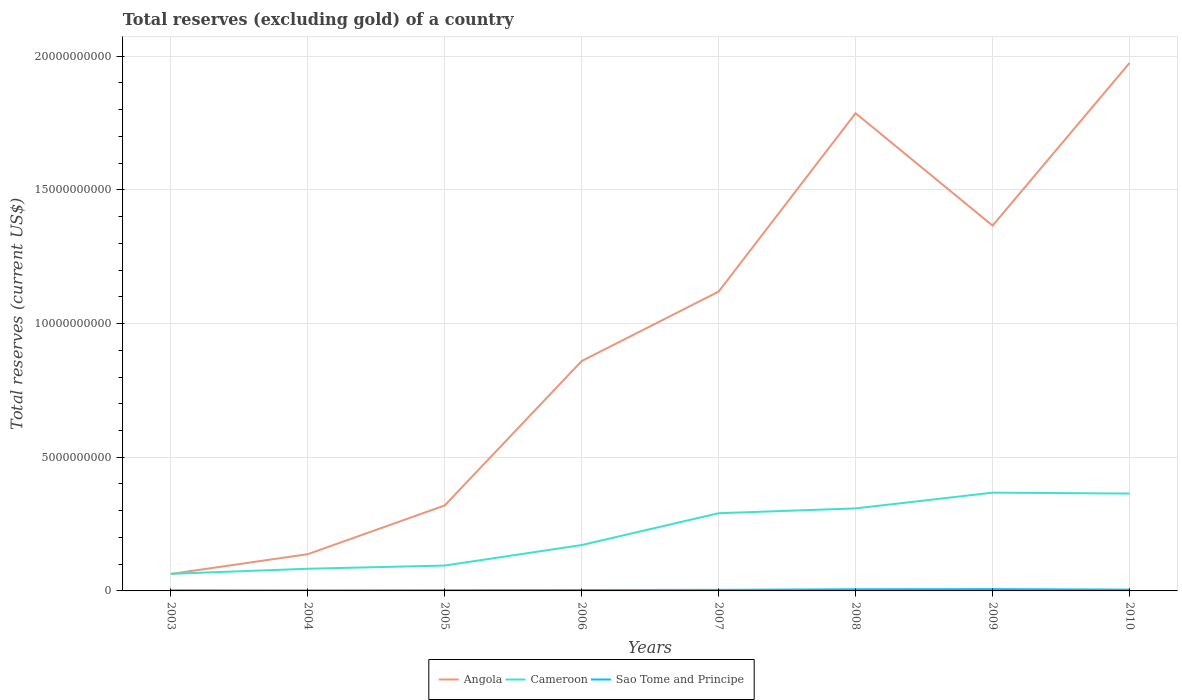How many different coloured lines are there?
Offer a terse response. 3. Does the line corresponding to Cameroon intersect with the line corresponding to Angola?
Offer a very short reply. Yes. Across all years, what is the maximum total reserves (excluding gold) in Cameroon?
Make the answer very short. 6.40e+08. What is the total total reserves (excluding gold) in Sao Tome and Principe in the graph?
Offer a terse response. -2.71e+07. What is the difference between the highest and the second highest total reserves (excluding gold) in Cameroon?
Your response must be concise. 3.04e+09. Is the total reserves (excluding gold) in Sao Tome and Principe strictly greater than the total reserves (excluding gold) in Angola over the years?
Provide a short and direct response. Yes. How many lines are there?
Make the answer very short. 3. What is the difference between two consecutive major ticks on the Y-axis?
Make the answer very short. 5.00e+09. Are the values on the major ticks of Y-axis written in scientific E-notation?
Make the answer very short. No. How many legend labels are there?
Your answer should be very brief. 3. How are the legend labels stacked?
Provide a short and direct response. Horizontal. What is the title of the graph?
Your answer should be very brief. Total reserves (excluding gold) of a country. What is the label or title of the X-axis?
Provide a succinct answer. Years. What is the label or title of the Y-axis?
Give a very brief answer. Total reserves (current US$). What is the Total reserves (current US$) of Angola in 2003?
Give a very brief answer. 6.34e+08. What is the Total reserves (current US$) of Cameroon in 2003?
Make the answer very short. 6.40e+08. What is the Total reserves (current US$) of Sao Tome and Principe in 2003?
Your answer should be compact. 2.55e+07. What is the Total reserves (current US$) of Angola in 2004?
Keep it short and to the point. 1.37e+09. What is the Total reserves (current US$) in Cameroon in 2004?
Your response must be concise. 8.29e+08. What is the Total reserves (current US$) of Sao Tome and Principe in 2004?
Give a very brief answer. 1.95e+07. What is the Total reserves (current US$) in Angola in 2005?
Make the answer very short. 3.20e+09. What is the Total reserves (current US$) in Cameroon in 2005?
Offer a very short reply. 9.49e+08. What is the Total reserves (current US$) in Sao Tome and Principe in 2005?
Make the answer very short. 2.67e+07. What is the Total reserves (current US$) in Angola in 2006?
Provide a succinct answer. 8.60e+09. What is the Total reserves (current US$) in Cameroon in 2006?
Provide a succinct answer. 1.72e+09. What is the Total reserves (current US$) of Sao Tome and Principe in 2006?
Your response must be concise. 3.42e+07. What is the Total reserves (current US$) of Angola in 2007?
Give a very brief answer. 1.12e+1. What is the Total reserves (current US$) in Cameroon in 2007?
Keep it short and to the point. 2.91e+09. What is the Total reserves (current US$) in Sao Tome and Principe in 2007?
Your answer should be very brief. 3.93e+07. What is the Total reserves (current US$) in Angola in 2008?
Your answer should be compact. 1.79e+1. What is the Total reserves (current US$) of Cameroon in 2008?
Keep it short and to the point. 3.09e+09. What is the Total reserves (current US$) in Sao Tome and Principe in 2008?
Ensure brevity in your answer.  6.13e+07. What is the Total reserves (current US$) in Angola in 2009?
Your response must be concise. 1.37e+1. What is the Total reserves (current US$) in Cameroon in 2009?
Ensure brevity in your answer.  3.68e+09. What is the Total reserves (current US$) of Sao Tome and Principe in 2009?
Make the answer very short. 6.67e+07. What is the Total reserves (current US$) of Angola in 2010?
Ensure brevity in your answer.  1.97e+1. What is the Total reserves (current US$) in Cameroon in 2010?
Ensure brevity in your answer.  3.64e+09. What is the Total reserves (current US$) of Sao Tome and Principe in 2010?
Give a very brief answer. 4.82e+07. Across all years, what is the maximum Total reserves (current US$) in Angola?
Your response must be concise. 1.97e+1. Across all years, what is the maximum Total reserves (current US$) in Cameroon?
Give a very brief answer. 3.68e+09. Across all years, what is the maximum Total reserves (current US$) in Sao Tome and Principe?
Make the answer very short. 6.67e+07. Across all years, what is the minimum Total reserves (current US$) of Angola?
Ensure brevity in your answer.  6.34e+08. Across all years, what is the minimum Total reserves (current US$) of Cameroon?
Provide a short and direct response. 6.40e+08. Across all years, what is the minimum Total reserves (current US$) in Sao Tome and Principe?
Your answer should be very brief. 1.95e+07. What is the total Total reserves (current US$) in Angola in the graph?
Ensure brevity in your answer.  7.63e+1. What is the total Total reserves (current US$) of Cameroon in the graph?
Ensure brevity in your answer.  1.74e+1. What is the total Total reserves (current US$) in Sao Tome and Principe in the graph?
Your answer should be compact. 3.21e+08. What is the difference between the Total reserves (current US$) in Angola in 2003 and that in 2004?
Your response must be concise. -7.40e+08. What is the difference between the Total reserves (current US$) of Cameroon in 2003 and that in 2004?
Your response must be concise. -1.90e+08. What is the difference between the Total reserves (current US$) in Sao Tome and Principe in 2003 and that in 2004?
Offer a terse response. 5.97e+06. What is the difference between the Total reserves (current US$) in Angola in 2003 and that in 2005?
Your response must be concise. -2.56e+09. What is the difference between the Total reserves (current US$) of Cameroon in 2003 and that in 2005?
Offer a terse response. -3.10e+08. What is the difference between the Total reserves (current US$) in Sao Tome and Principe in 2003 and that in 2005?
Keep it short and to the point. -1.23e+06. What is the difference between the Total reserves (current US$) of Angola in 2003 and that in 2006?
Make the answer very short. -7.96e+09. What is the difference between the Total reserves (current US$) of Cameroon in 2003 and that in 2006?
Your response must be concise. -1.08e+09. What is the difference between the Total reserves (current US$) in Sao Tome and Principe in 2003 and that in 2006?
Provide a succinct answer. -8.71e+06. What is the difference between the Total reserves (current US$) in Angola in 2003 and that in 2007?
Your response must be concise. -1.06e+1. What is the difference between the Total reserves (current US$) in Cameroon in 2003 and that in 2007?
Keep it short and to the point. -2.27e+09. What is the difference between the Total reserves (current US$) of Sao Tome and Principe in 2003 and that in 2007?
Your response must be concise. -1.39e+07. What is the difference between the Total reserves (current US$) in Angola in 2003 and that in 2008?
Offer a terse response. -1.72e+1. What is the difference between the Total reserves (current US$) in Cameroon in 2003 and that in 2008?
Provide a succinct answer. -2.45e+09. What is the difference between the Total reserves (current US$) in Sao Tome and Principe in 2003 and that in 2008?
Provide a succinct answer. -3.58e+07. What is the difference between the Total reserves (current US$) of Angola in 2003 and that in 2009?
Make the answer very short. -1.30e+1. What is the difference between the Total reserves (current US$) of Cameroon in 2003 and that in 2009?
Provide a short and direct response. -3.04e+09. What is the difference between the Total reserves (current US$) in Sao Tome and Principe in 2003 and that in 2009?
Make the answer very short. -4.12e+07. What is the difference between the Total reserves (current US$) in Angola in 2003 and that in 2010?
Offer a very short reply. -1.91e+1. What is the difference between the Total reserves (current US$) in Cameroon in 2003 and that in 2010?
Keep it short and to the point. -3.00e+09. What is the difference between the Total reserves (current US$) in Sao Tome and Principe in 2003 and that in 2010?
Your answer should be very brief. -2.27e+07. What is the difference between the Total reserves (current US$) of Angola in 2004 and that in 2005?
Your answer should be compact. -1.82e+09. What is the difference between the Total reserves (current US$) of Cameroon in 2004 and that in 2005?
Offer a terse response. -1.20e+08. What is the difference between the Total reserves (current US$) in Sao Tome and Principe in 2004 and that in 2005?
Provide a short and direct response. -7.20e+06. What is the difference between the Total reserves (current US$) of Angola in 2004 and that in 2006?
Your answer should be very brief. -7.22e+09. What is the difference between the Total reserves (current US$) in Cameroon in 2004 and that in 2006?
Make the answer very short. -8.87e+08. What is the difference between the Total reserves (current US$) in Sao Tome and Principe in 2004 and that in 2006?
Provide a short and direct response. -1.47e+07. What is the difference between the Total reserves (current US$) of Angola in 2004 and that in 2007?
Give a very brief answer. -9.82e+09. What is the difference between the Total reserves (current US$) of Cameroon in 2004 and that in 2007?
Offer a very short reply. -2.08e+09. What is the difference between the Total reserves (current US$) in Sao Tome and Principe in 2004 and that in 2007?
Your answer should be compact. -1.98e+07. What is the difference between the Total reserves (current US$) of Angola in 2004 and that in 2008?
Offer a very short reply. -1.65e+1. What is the difference between the Total reserves (current US$) in Cameroon in 2004 and that in 2008?
Offer a very short reply. -2.26e+09. What is the difference between the Total reserves (current US$) in Sao Tome and Principe in 2004 and that in 2008?
Your response must be concise. -4.18e+07. What is the difference between the Total reserves (current US$) of Angola in 2004 and that in 2009?
Your answer should be compact. -1.23e+1. What is the difference between the Total reserves (current US$) in Cameroon in 2004 and that in 2009?
Provide a succinct answer. -2.85e+09. What is the difference between the Total reserves (current US$) in Sao Tome and Principe in 2004 and that in 2009?
Your response must be concise. -4.72e+07. What is the difference between the Total reserves (current US$) of Angola in 2004 and that in 2010?
Keep it short and to the point. -1.84e+1. What is the difference between the Total reserves (current US$) in Cameroon in 2004 and that in 2010?
Offer a very short reply. -2.81e+09. What is the difference between the Total reserves (current US$) of Sao Tome and Principe in 2004 and that in 2010?
Offer a terse response. -2.87e+07. What is the difference between the Total reserves (current US$) in Angola in 2005 and that in 2006?
Provide a short and direct response. -5.40e+09. What is the difference between the Total reserves (current US$) in Cameroon in 2005 and that in 2006?
Ensure brevity in your answer.  -7.67e+08. What is the difference between the Total reserves (current US$) of Sao Tome and Principe in 2005 and that in 2006?
Make the answer very short. -7.48e+06. What is the difference between the Total reserves (current US$) in Angola in 2005 and that in 2007?
Give a very brief answer. -8.00e+09. What is the difference between the Total reserves (current US$) in Cameroon in 2005 and that in 2007?
Offer a very short reply. -1.96e+09. What is the difference between the Total reserves (current US$) of Sao Tome and Principe in 2005 and that in 2007?
Give a very brief answer. -1.26e+07. What is the difference between the Total reserves (current US$) in Angola in 2005 and that in 2008?
Provide a succinct answer. -1.47e+1. What is the difference between the Total reserves (current US$) in Cameroon in 2005 and that in 2008?
Ensure brevity in your answer.  -2.14e+09. What is the difference between the Total reserves (current US$) in Sao Tome and Principe in 2005 and that in 2008?
Keep it short and to the point. -3.46e+07. What is the difference between the Total reserves (current US$) in Angola in 2005 and that in 2009?
Your answer should be very brief. -1.05e+1. What is the difference between the Total reserves (current US$) of Cameroon in 2005 and that in 2009?
Provide a succinct answer. -2.73e+09. What is the difference between the Total reserves (current US$) of Sao Tome and Principe in 2005 and that in 2009?
Your response must be concise. -4.00e+07. What is the difference between the Total reserves (current US$) in Angola in 2005 and that in 2010?
Make the answer very short. -1.66e+1. What is the difference between the Total reserves (current US$) in Cameroon in 2005 and that in 2010?
Make the answer very short. -2.69e+09. What is the difference between the Total reserves (current US$) in Sao Tome and Principe in 2005 and that in 2010?
Give a very brief answer. -2.15e+07. What is the difference between the Total reserves (current US$) of Angola in 2006 and that in 2007?
Make the answer very short. -2.60e+09. What is the difference between the Total reserves (current US$) of Cameroon in 2006 and that in 2007?
Keep it short and to the point. -1.19e+09. What is the difference between the Total reserves (current US$) in Sao Tome and Principe in 2006 and that in 2007?
Provide a succinct answer. -5.15e+06. What is the difference between the Total reserves (current US$) in Angola in 2006 and that in 2008?
Ensure brevity in your answer.  -9.27e+09. What is the difference between the Total reserves (current US$) of Cameroon in 2006 and that in 2008?
Give a very brief answer. -1.37e+09. What is the difference between the Total reserves (current US$) of Sao Tome and Principe in 2006 and that in 2008?
Offer a terse response. -2.71e+07. What is the difference between the Total reserves (current US$) in Angola in 2006 and that in 2009?
Give a very brief answer. -5.07e+09. What is the difference between the Total reserves (current US$) of Cameroon in 2006 and that in 2009?
Offer a very short reply. -1.96e+09. What is the difference between the Total reserves (current US$) in Sao Tome and Principe in 2006 and that in 2009?
Make the answer very short. -3.25e+07. What is the difference between the Total reserves (current US$) of Angola in 2006 and that in 2010?
Offer a very short reply. -1.12e+1. What is the difference between the Total reserves (current US$) in Cameroon in 2006 and that in 2010?
Your answer should be compact. -1.93e+09. What is the difference between the Total reserves (current US$) of Sao Tome and Principe in 2006 and that in 2010?
Keep it short and to the point. -1.40e+07. What is the difference between the Total reserves (current US$) in Angola in 2007 and that in 2008?
Your answer should be compact. -6.67e+09. What is the difference between the Total reserves (current US$) in Cameroon in 2007 and that in 2008?
Your response must be concise. -1.80e+08. What is the difference between the Total reserves (current US$) of Sao Tome and Principe in 2007 and that in 2008?
Make the answer very short. -2.20e+07. What is the difference between the Total reserves (current US$) in Angola in 2007 and that in 2009?
Ensure brevity in your answer.  -2.47e+09. What is the difference between the Total reserves (current US$) of Cameroon in 2007 and that in 2009?
Your answer should be very brief. -7.69e+08. What is the difference between the Total reserves (current US$) of Sao Tome and Principe in 2007 and that in 2009?
Give a very brief answer. -2.73e+07. What is the difference between the Total reserves (current US$) of Angola in 2007 and that in 2010?
Provide a succinct answer. -8.55e+09. What is the difference between the Total reserves (current US$) in Cameroon in 2007 and that in 2010?
Your response must be concise. -7.36e+08. What is the difference between the Total reserves (current US$) of Sao Tome and Principe in 2007 and that in 2010?
Your answer should be very brief. -8.84e+06. What is the difference between the Total reserves (current US$) in Angola in 2008 and that in 2009?
Offer a very short reply. 4.21e+09. What is the difference between the Total reserves (current US$) in Cameroon in 2008 and that in 2009?
Your response must be concise. -5.89e+08. What is the difference between the Total reserves (current US$) in Sao Tome and Principe in 2008 and that in 2009?
Ensure brevity in your answer.  -5.37e+06. What is the difference between the Total reserves (current US$) in Angola in 2008 and that in 2010?
Offer a very short reply. -1.88e+09. What is the difference between the Total reserves (current US$) of Cameroon in 2008 and that in 2010?
Your answer should be compact. -5.56e+08. What is the difference between the Total reserves (current US$) in Sao Tome and Principe in 2008 and that in 2010?
Offer a terse response. 1.31e+07. What is the difference between the Total reserves (current US$) in Angola in 2009 and that in 2010?
Offer a terse response. -6.09e+09. What is the difference between the Total reserves (current US$) in Cameroon in 2009 and that in 2010?
Offer a terse response. 3.29e+07. What is the difference between the Total reserves (current US$) in Sao Tome and Principe in 2009 and that in 2010?
Give a very brief answer. 1.85e+07. What is the difference between the Total reserves (current US$) of Angola in 2003 and the Total reserves (current US$) of Cameroon in 2004?
Provide a succinct answer. -1.95e+08. What is the difference between the Total reserves (current US$) in Angola in 2003 and the Total reserves (current US$) in Sao Tome and Principe in 2004?
Make the answer very short. 6.15e+08. What is the difference between the Total reserves (current US$) of Cameroon in 2003 and the Total reserves (current US$) of Sao Tome and Principe in 2004?
Your answer should be very brief. 6.20e+08. What is the difference between the Total reserves (current US$) in Angola in 2003 and the Total reserves (current US$) in Cameroon in 2005?
Give a very brief answer. -3.15e+08. What is the difference between the Total reserves (current US$) in Angola in 2003 and the Total reserves (current US$) in Sao Tome and Principe in 2005?
Your response must be concise. 6.07e+08. What is the difference between the Total reserves (current US$) of Cameroon in 2003 and the Total reserves (current US$) of Sao Tome and Principe in 2005?
Offer a very short reply. 6.13e+08. What is the difference between the Total reserves (current US$) of Angola in 2003 and the Total reserves (current US$) of Cameroon in 2006?
Your answer should be compact. -1.08e+09. What is the difference between the Total reserves (current US$) of Angola in 2003 and the Total reserves (current US$) of Sao Tome and Principe in 2006?
Keep it short and to the point. 6.00e+08. What is the difference between the Total reserves (current US$) of Cameroon in 2003 and the Total reserves (current US$) of Sao Tome and Principe in 2006?
Make the answer very short. 6.05e+08. What is the difference between the Total reserves (current US$) in Angola in 2003 and the Total reserves (current US$) in Cameroon in 2007?
Give a very brief answer. -2.27e+09. What is the difference between the Total reserves (current US$) in Angola in 2003 and the Total reserves (current US$) in Sao Tome and Principe in 2007?
Offer a very short reply. 5.95e+08. What is the difference between the Total reserves (current US$) in Cameroon in 2003 and the Total reserves (current US$) in Sao Tome and Principe in 2007?
Give a very brief answer. 6.00e+08. What is the difference between the Total reserves (current US$) of Angola in 2003 and the Total reserves (current US$) of Cameroon in 2008?
Make the answer very short. -2.45e+09. What is the difference between the Total reserves (current US$) in Angola in 2003 and the Total reserves (current US$) in Sao Tome and Principe in 2008?
Your answer should be very brief. 5.73e+08. What is the difference between the Total reserves (current US$) in Cameroon in 2003 and the Total reserves (current US$) in Sao Tome and Principe in 2008?
Offer a terse response. 5.78e+08. What is the difference between the Total reserves (current US$) in Angola in 2003 and the Total reserves (current US$) in Cameroon in 2009?
Your response must be concise. -3.04e+09. What is the difference between the Total reserves (current US$) of Angola in 2003 and the Total reserves (current US$) of Sao Tome and Principe in 2009?
Offer a very short reply. 5.68e+08. What is the difference between the Total reserves (current US$) in Cameroon in 2003 and the Total reserves (current US$) in Sao Tome and Principe in 2009?
Your answer should be compact. 5.73e+08. What is the difference between the Total reserves (current US$) in Angola in 2003 and the Total reserves (current US$) in Cameroon in 2010?
Your answer should be compact. -3.01e+09. What is the difference between the Total reserves (current US$) of Angola in 2003 and the Total reserves (current US$) of Sao Tome and Principe in 2010?
Your response must be concise. 5.86e+08. What is the difference between the Total reserves (current US$) of Cameroon in 2003 and the Total reserves (current US$) of Sao Tome and Principe in 2010?
Offer a terse response. 5.91e+08. What is the difference between the Total reserves (current US$) in Angola in 2004 and the Total reserves (current US$) in Cameroon in 2005?
Provide a succinct answer. 4.25e+08. What is the difference between the Total reserves (current US$) of Angola in 2004 and the Total reserves (current US$) of Sao Tome and Principe in 2005?
Keep it short and to the point. 1.35e+09. What is the difference between the Total reserves (current US$) in Cameroon in 2004 and the Total reserves (current US$) in Sao Tome and Principe in 2005?
Your response must be concise. 8.03e+08. What is the difference between the Total reserves (current US$) in Angola in 2004 and the Total reserves (current US$) in Cameroon in 2006?
Your response must be concise. -3.42e+08. What is the difference between the Total reserves (current US$) in Angola in 2004 and the Total reserves (current US$) in Sao Tome and Principe in 2006?
Make the answer very short. 1.34e+09. What is the difference between the Total reserves (current US$) of Cameroon in 2004 and the Total reserves (current US$) of Sao Tome and Principe in 2006?
Make the answer very short. 7.95e+08. What is the difference between the Total reserves (current US$) in Angola in 2004 and the Total reserves (current US$) in Cameroon in 2007?
Provide a succinct answer. -1.53e+09. What is the difference between the Total reserves (current US$) of Angola in 2004 and the Total reserves (current US$) of Sao Tome and Principe in 2007?
Provide a succinct answer. 1.33e+09. What is the difference between the Total reserves (current US$) of Cameroon in 2004 and the Total reserves (current US$) of Sao Tome and Principe in 2007?
Offer a terse response. 7.90e+08. What is the difference between the Total reserves (current US$) in Angola in 2004 and the Total reserves (current US$) in Cameroon in 2008?
Offer a very short reply. -1.71e+09. What is the difference between the Total reserves (current US$) of Angola in 2004 and the Total reserves (current US$) of Sao Tome and Principe in 2008?
Ensure brevity in your answer.  1.31e+09. What is the difference between the Total reserves (current US$) of Cameroon in 2004 and the Total reserves (current US$) of Sao Tome and Principe in 2008?
Make the answer very short. 7.68e+08. What is the difference between the Total reserves (current US$) of Angola in 2004 and the Total reserves (current US$) of Cameroon in 2009?
Offer a terse response. -2.30e+09. What is the difference between the Total reserves (current US$) in Angola in 2004 and the Total reserves (current US$) in Sao Tome and Principe in 2009?
Offer a very short reply. 1.31e+09. What is the difference between the Total reserves (current US$) of Cameroon in 2004 and the Total reserves (current US$) of Sao Tome and Principe in 2009?
Offer a terse response. 7.63e+08. What is the difference between the Total reserves (current US$) of Angola in 2004 and the Total reserves (current US$) of Cameroon in 2010?
Make the answer very short. -2.27e+09. What is the difference between the Total reserves (current US$) in Angola in 2004 and the Total reserves (current US$) in Sao Tome and Principe in 2010?
Provide a short and direct response. 1.33e+09. What is the difference between the Total reserves (current US$) in Cameroon in 2004 and the Total reserves (current US$) in Sao Tome and Principe in 2010?
Your answer should be compact. 7.81e+08. What is the difference between the Total reserves (current US$) in Angola in 2005 and the Total reserves (current US$) in Cameroon in 2006?
Make the answer very short. 1.48e+09. What is the difference between the Total reserves (current US$) of Angola in 2005 and the Total reserves (current US$) of Sao Tome and Principe in 2006?
Offer a terse response. 3.16e+09. What is the difference between the Total reserves (current US$) in Cameroon in 2005 and the Total reserves (current US$) in Sao Tome and Principe in 2006?
Give a very brief answer. 9.15e+08. What is the difference between the Total reserves (current US$) in Angola in 2005 and the Total reserves (current US$) in Cameroon in 2007?
Give a very brief answer. 2.90e+08. What is the difference between the Total reserves (current US$) in Angola in 2005 and the Total reserves (current US$) in Sao Tome and Principe in 2007?
Provide a succinct answer. 3.16e+09. What is the difference between the Total reserves (current US$) in Cameroon in 2005 and the Total reserves (current US$) in Sao Tome and Principe in 2007?
Give a very brief answer. 9.10e+08. What is the difference between the Total reserves (current US$) of Angola in 2005 and the Total reserves (current US$) of Cameroon in 2008?
Provide a short and direct response. 1.10e+08. What is the difference between the Total reserves (current US$) of Angola in 2005 and the Total reserves (current US$) of Sao Tome and Principe in 2008?
Offer a terse response. 3.14e+09. What is the difference between the Total reserves (current US$) of Cameroon in 2005 and the Total reserves (current US$) of Sao Tome and Principe in 2008?
Offer a very short reply. 8.88e+08. What is the difference between the Total reserves (current US$) in Angola in 2005 and the Total reserves (current US$) in Cameroon in 2009?
Offer a terse response. -4.79e+08. What is the difference between the Total reserves (current US$) in Angola in 2005 and the Total reserves (current US$) in Sao Tome and Principe in 2009?
Your answer should be compact. 3.13e+09. What is the difference between the Total reserves (current US$) in Cameroon in 2005 and the Total reserves (current US$) in Sao Tome and Principe in 2009?
Provide a succinct answer. 8.83e+08. What is the difference between the Total reserves (current US$) in Angola in 2005 and the Total reserves (current US$) in Cameroon in 2010?
Your answer should be compact. -4.46e+08. What is the difference between the Total reserves (current US$) in Angola in 2005 and the Total reserves (current US$) in Sao Tome and Principe in 2010?
Make the answer very short. 3.15e+09. What is the difference between the Total reserves (current US$) of Cameroon in 2005 and the Total reserves (current US$) of Sao Tome and Principe in 2010?
Make the answer very short. 9.01e+08. What is the difference between the Total reserves (current US$) in Angola in 2006 and the Total reserves (current US$) in Cameroon in 2007?
Offer a very short reply. 5.69e+09. What is the difference between the Total reserves (current US$) of Angola in 2006 and the Total reserves (current US$) of Sao Tome and Principe in 2007?
Your answer should be compact. 8.56e+09. What is the difference between the Total reserves (current US$) of Cameroon in 2006 and the Total reserves (current US$) of Sao Tome and Principe in 2007?
Your answer should be very brief. 1.68e+09. What is the difference between the Total reserves (current US$) in Angola in 2006 and the Total reserves (current US$) in Cameroon in 2008?
Offer a terse response. 5.51e+09. What is the difference between the Total reserves (current US$) in Angola in 2006 and the Total reserves (current US$) in Sao Tome and Principe in 2008?
Provide a succinct answer. 8.54e+09. What is the difference between the Total reserves (current US$) of Cameroon in 2006 and the Total reserves (current US$) of Sao Tome and Principe in 2008?
Provide a succinct answer. 1.65e+09. What is the difference between the Total reserves (current US$) of Angola in 2006 and the Total reserves (current US$) of Cameroon in 2009?
Give a very brief answer. 4.92e+09. What is the difference between the Total reserves (current US$) of Angola in 2006 and the Total reserves (current US$) of Sao Tome and Principe in 2009?
Your response must be concise. 8.53e+09. What is the difference between the Total reserves (current US$) in Cameroon in 2006 and the Total reserves (current US$) in Sao Tome and Principe in 2009?
Your response must be concise. 1.65e+09. What is the difference between the Total reserves (current US$) of Angola in 2006 and the Total reserves (current US$) of Cameroon in 2010?
Your answer should be very brief. 4.96e+09. What is the difference between the Total reserves (current US$) of Angola in 2006 and the Total reserves (current US$) of Sao Tome and Principe in 2010?
Offer a very short reply. 8.55e+09. What is the difference between the Total reserves (current US$) of Cameroon in 2006 and the Total reserves (current US$) of Sao Tome and Principe in 2010?
Keep it short and to the point. 1.67e+09. What is the difference between the Total reserves (current US$) of Angola in 2007 and the Total reserves (current US$) of Cameroon in 2008?
Keep it short and to the point. 8.11e+09. What is the difference between the Total reserves (current US$) of Angola in 2007 and the Total reserves (current US$) of Sao Tome and Principe in 2008?
Your answer should be compact. 1.11e+1. What is the difference between the Total reserves (current US$) of Cameroon in 2007 and the Total reserves (current US$) of Sao Tome and Principe in 2008?
Offer a terse response. 2.85e+09. What is the difference between the Total reserves (current US$) in Angola in 2007 and the Total reserves (current US$) in Cameroon in 2009?
Offer a terse response. 7.52e+09. What is the difference between the Total reserves (current US$) of Angola in 2007 and the Total reserves (current US$) of Sao Tome and Principe in 2009?
Your answer should be compact. 1.11e+1. What is the difference between the Total reserves (current US$) in Cameroon in 2007 and the Total reserves (current US$) in Sao Tome and Principe in 2009?
Keep it short and to the point. 2.84e+09. What is the difference between the Total reserves (current US$) in Angola in 2007 and the Total reserves (current US$) in Cameroon in 2010?
Your answer should be compact. 7.55e+09. What is the difference between the Total reserves (current US$) in Angola in 2007 and the Total reserves (current US$) in Sao Tome and Principe in 2010?
Your answer should be very brief. 1.11e+1. What is the difference between the Total reserves (current US$) in Cameroon in 2007 and the Total reserves (current US$) in Sao Tome and Principe in 2010?
Your answer should be compact. 2.86e+09. What is the difference between the Total reserves (current US$) of Angola in 2008 and the Total reserves (current US$) of Cameroon in 2009?
Give a very brief answer. 1.42e+1. What is the difference between the Total reserves (current US$) of Angola in 2008 and the Total reserves (current US$) of Sao Tome and Principe in 2009?
Provide a succinct answer. 1.78e+1. What is the difference between the Total reserves (current US$) of Cameroon in 2008 and the Total reserves (current US$) of Sao Tome and Principe in 2009?
Keep it short and to the point. 3.02e+09. What is the difference between the Total reserves (current US$) in Angola in 2008 and the Total reserves (current US$) in Cameroon in 2010?
Provide a succinct answer. 1.42e+1. What is the difference between the Total reserves (current US$) in Angola in 2008 and the Total reserves (current US$) in Sao Tome and Principe in 2010?
Provide a short and direct response. 1.78e+1. What is the difference between the Total reserves (current US$) of Cameroon in 2008 and the Total reserves (current US$) of Sao Tome and Principe in 2010?
Your response must be concise. 3.04e+09. What is the difference between the Total reserves (current US$) of Angola in 2009 and the Total reserves (current US$) of Cameroon in 2010?
Ensure brevity in your answer.  1.00e+1. What is the difference between the Total reserves (current US$) of Angola in 2009 and the Total reserves (current US$) of Sao Tome and Principe in 2010?
Provide a short and direct response. 1.36e+1. What is the difference between the Total reserves (current US$) in Cameroon in 2009 and the Total reserves (current US$) in Sao Tome and Principe in 2010?
Ensure brevity in your answer.  3.63e+09. What is the average Total reserves (current US$) of Angola per year?
Provide a succinct answer. 9.54e+09. What is the average Total reserves (current US$) in Cameroon per year?
Your answer should be very brief. 2.18e+09. What is the average Total reserves (current US$) in Sao Tome and Principe per year?
Provide a succinct answer. 4.02e+07. In the year 2003, what is the difference between the Total reserves (current US$) in Angola and Total reserves (current US$) in Cameroon?
Offer a terse response. -5.44e+06. In the year 2003, what is the difference between the Total reserves (current US$) of Angola and Total reserves (current US$) of Sao Tome and Principe?
Keep it short and to the point. 6.09e+08. In the year 2003, what is the difference between the Total reserves (current US$) of Cameroon and Total reserves (current US$) of Sao Tome and Principe?
Make the answer very short. 6.14e+08. In the year 2004, what is the difference between the Total reserves (current US$) of Angola and Total reserves (current US$) of Cameroon?
Make the answer very short. 5.45e+08. In the year 2004, what is the difference between the Total reserves (current US$) in Angola and Total reserves (current US$) in Sao Tome and Principe?
Provide a short and direct response. 1.35e+09. In the year 2004, what is the difference between the Total reserves (current US$) in Cameroon and Total reserves (current US$) in Sao Tome and Principe?
Provide a succinct answer. 8.10e+08. In the year 2005, what is the difference between the Total reserves (current US$) of Angola and Total reserves (current US$) of Cameroon?
Provide a succinct answer. 2.25e+09. In the year 2005, what is the difference between the Total reserves (current US$) in Angola and Total reserves (current US$) in Sao Tome and Principe?
Your answer should be compact. 3.17e+09. In the year 2005, what is the difference between the Total reserves (current US$) of Cameroon and Total reserves (current US$) of Sao Tome and Principe?
Your answer should be very brief. 9.23e+08. In the year 2006, what is the difference between the Total reserves (current US$) in Angola and Total reserves (current US$) in Cameroon?
Provide a succinct answer. 6.88e+09. In the year 2006, what is the difference between the Total reserves (current US$) of Angola and Total reserves (current US$) of Sao Tome and Principe?
Your answer should be compact. 8.56e+09. In the year 2006, what is the difference between the Total reserves (current US$) of Cameroon and Total reserves (current US$) of Sao Tome and Principe?
Make the answer very short. 1.68e+09. In the year 2007, what is the difference between the Total reserves (current US$) in Angola and Total reserves (current US$) in Cameroon?
Keep it short and to the point. 8.29e+09. In the year 2007, what is the difference between the Total reserves (current US$) in Angola and Total reserves (current US$) in Sao Tome and Principe?
Your response must be concise. 1.12e+1. In the year 2007, what is the difference between the Total reserves (current US$) of Cameroon and Total reserves (current US$) of Sao Tome and Principe?
Provide a succinct answer. 2.87e+09. In the year 2008, what is the difference between the Total reserves (current US$) of Angola and Total reserves (current US$) of Cameroon?
Your answer should be very brief. 1.48e+1. In the year 2008, what is the difference between the Total reserves (current US$) of Angola and Total reserves (current US$) of Sao Tome and Principe?
Offer a very short reply. 1.78e+1. In the year 2008, what is the difference between the Total reserves (current US$) of Cameroon and Total reserves (current US$) of Sao Tome and Principe?
Provide a succinct answer. 3.03e+09. In the year 2009, what is the difference between the Total reserves (current US$) of Angola and Total reserves (current US$) of Cameroon?
Ensure brevity in your answer.  9.99e+09. In the year 2009, what is the difference between the Total reserves (current US$) in Angola and Total reserves (current US$) in Sao Tome and Principe?
Make the answer very short. 1.36e+1. In the year 2009, what is the difference between the Total reserves (current US$) in Cameroon and Total reserves (current US$) in Sao Tome and Principe?
Give a very brief answer. 3.61e+09. In the year 2010, what is the difference between the Total reserves (current US$) in Angola and Total reserves (current US$) in Cameroon?
Ensure brevity in your answer.  1.61e+1. In the year 2010, what is the difference between the Total reserves (current US$) of Angola and Total reserves (current US$) of Sao Tome and Principe?
Offer a terse response. 1.97e+1. In the year 2010, what is the difference between the Total reserves (current US$) in Cameroon and Total reserves (current US$) in Sao Tome and Principe?
Your response must be concise. 3.59e+09. What is the ratio of the Total reserves (current US$) of Angola in 2003 to that in 2004?
Provide a succinct answer. 0.46. What is the ratio of the Total reserves (current US$) in Cameroon in 2003 to that in 2004?
Make the answer very short. 0.77. What is the ratio of the Total reserves (current US$) in Sao Tome and Principe in 2003 to that in 2004?
Your answer should be very brief. 1.31. What is the ratio of the Total reserves (current US$) in Angola in 2003 to that in 2005?
Offer a terse response. 0.2. What is the ratio of the Total reserves (current US$) of Cameroon in 2003 to that in 2005?
Offer a terse response. 0.67. What is the ratio of the Total reserves (current US$) of Sao Tome and Principe in 2003 to that in 2005?
Offer a very short reply. 0.95. What is the ratio of the Total reserves (current US$) in Angola in 2003 to that in 2006?
Give a very brief answer. 0.07. What is the ratio of the Total reserves (current US$) of Cameroon in 2003 to that in 2006?
Make the answer very short. 0.37. What is the ratio of the Total reserves (current US$) of Sao Tome and Principe in 2003 to that in 2006?
Offer a very short reply. 0.75. What is the ratio of the Total reserves (current US$) of Angola in 2003 to that in 2007?
Ensure brevity in your answer.  0.06. What is the ratio of the Total reserves (current US$) in Cameroon in 2003 to that in 2007?
Give a very brief answer. 0.22. What is the ratio of the Total reserves (current US$) in Sao Tome and Principe in 2003 to that in 2007?
Offer a very short reply. 0.65. What is the ratio of the Total reserves (current US$) of Angola in 2003 to that in 2008?
Provide a succinct answer. 0.04. What is the ratio of the Total reserves (current US$) in Cameroon in 2003 to that in 2008?
Provide a succinct answer. 0.21. What is the ratio of the Total reserves (current US$) in Sao Tome and Principe in 2003 to that in 2008?
Your answer should be very brief. 0.42. What is the ratio of the Total reserves (current US$) in Angola in 2003 to that in 2009?
Your response must be concise. 0.05. What is the ratio of the Total reserves (current US$) of Cameroon in 2003 to that in 2009?
Provide a succinct answer. 0.17. What is the ratio of the Total reserves (current US$) in Sao Tome and Principe in 2003 to that in 2009?
Provide a succinct answer. 0.38. What is the ratio of the Total reserves (current US$) of Angola in 2003 to that in 2010?
Provide a succinct answer. 0.03. What is the ratio of the Total reserves (current US$) of Cameroon in 2003 to that in 2010?
Offer a terse response. 0.18. What is the ratio of the Total reserves (current US$) of Sao Tome and Principe in 2003 to that in 2010?
Make the answer very short. 0.53. What is the ratio of the Total reserves (current US$) in Angola in 2004 to that in 2005?
Ensure brevity in your answer.  0.43. What is the ratio of the Total reserves (current US$) of Cameroon in 2004 to that in 2005?
Provide a succinct answer. 0.87. What is the ratio of the Total reserves (current US$) of Sao Tome and Principe in 2004 to that in 2005?
Make the answer very short. 0.73. What is the ratio of the Total reserves (current US$) in Angola in 2004 to that in 2006?
Give a very brief answer. 0.16. What is the ratio of the Total reserves (current US$) of Cameroon in 2004 to that in 2006?
Provide a short and direct response. 0.48. What is the ratio of the Total reserves (current US$) of Sao Tome and Principe in 2004 to that in 2006?
Ensure brevity in your answer.  0.57. What is the ratio of the Total reserves (current US$) in Angola in 2004 to that in 2007?
Give a very brief answer. 0.12. What is the ratio of the Total reserves (current US$) in Cameroon in 2004 to that in 2007?
Offer a terse response. 0.29. What is the ratio of the Total reserves (current US$) in Sao Tome and Principe in 2004 to that in 2007?
Provide a short and direct response. 0.5. What is the ratio of the Total reserves (current US$) in Angola in 2004 to that in 2008?
Offer a very short reply. 0.08. What is the ratio of the Total reserves (current US$) of Cameroon in 2004 to that in 2008?
Provide a succinct answer. 0.27. What is the ratio of the Total reserves (current US$) in Sao Tome and Principe in 2004 to that in 2008?
Your answer should be very brief. 0.32. What is the ratio of the Total reserves (current US$) of Angola in 2004 to that in 2009?
Make the answer very short. 0.1. What is the ratio of the Total reserves (current US$) in Cameroon in 2004 to that in 2009?
Keep it short and to the point. 0.23. What is the ratio of the Total reserves (current US$) of Sao Tome and Principe in 2004 to that in 2009?
Your answer should be very brief. 0.29. What is the ratio of the Total reserves (current US$) of Angola in 2004 to that in 2010?
Make the answer very short. 0.07. What is the ratio of the Total reserves (current US$) in Cameroon in 2004 to that in 2010?
Make the answer very short. 0.23. What is the ratio of the Total reserves (current US$) of Sao Tome and Principe in 2004 to that in 2010?
Offer a very short reply. 0.4. What is the ratio of the Total reserves (current US$) in Angola in 2005 to that in 2006?
Provide a short and direct response. 0.37. What is the ratio of the Total reserves (current US$) of Cameroon in 2005 to that in 2006?
Your answer should be very brief. 0.55. What is the ratio of the Total reserves (current US$) in Sao Tome and Principe in 2005 to that in 2006?
Ensure brevity in your answer.  0.78. What is the ratio of the Total reserves (current US$) in Angola in 2005 to that in 2007?
Your answer should be compact. 0.29. What is the ratio of the Total reserves (current US$) in Cameroon in 2005 to that in 2007?
Offer a very short reply. 0.33. What is the ratio of the Total reserves (current US$) of Sao Tome and Principe in 2005 to that in 2007?
Your answer should be compact. 0.68. What is the ratio of the Total reserves (current US$) in Angola in 2005 to that in 2008?
Your answer should be very brief. 0.18. What is the ratio of the Total reserves (current US$) of Cameroon in 2005 to that in 2008?
Give a very brief answer. 0.31. What is the ratio of the Total reserves (current US$) of Sao Tome and Principe in 2005 to that in 2008?
Offer a terse response. 0.44. What is the ratio of the Total reserves (current US$) of Angola in 2005 to that in 2009?
Make the answer very short. 0.23. What is the ratio of the Total reserves (current US$) in Cameroon in 2005 to that in 2009?
Your answer should be very brief. 0.26. What is the ratio of the Total reserves (current US$) of Sao Tome and Principe in 2005 to that in 2009?
Offer a terse response. 0.4. What is the ratio of the Total reserves (current US$) of Angola in 2005 to that in 2010?
Give a very brief answer. 0.16. What is the ratio of the Total reserves (current US$) in Cameroon in 2005 to that in 2010?
Provide a succinct answer. 0.26. What is the ratio of the Total reserves (current US$) of Sao Tome and Principe in 2005 to that in 2010?
Keep it short and to the point. 0.55. What is the ratio of the Total reserves (current US$) of Angola in 2006 to that in 2007?
Your response must be concise. 0.77. What is the ratio of the Total reserves (current US$) of Cameroon in 2006 to that in 2007?
Your response must be concise. 0.59. What is the ratio of the Total reserves (current US$) of Sao Tome and Principe in 2006 to that in 2007?
Your response must be concise. 0.87. What is the ratio of the Total reserves (current US$) of Angola in 2006 to that in 2008?
Ensure brevity in your answer.  0.48. What is the ratio of the Total reserves (current US$) in Cameroon in 2006 to that in 2008?
Offer a very short reply. 0.56. What is the ratio of the Total reserves (current US$) of Sao Tome and Principe in 2006 to that in 2008?
Your answer should be very brief. 0.56. What is the ratio of the Total reserves (current US$) of Angola in 2006 to that in 2009?
Your answer should be compact. 0.63. What is the ratio of the Total reserves (current US$) of Cameroon in 2006 to that in 2009?
Provide a short and direct response. 0.47. What is the ratio of the Total reserves (current US$) in Sao Tome and Principe in 2006 to that in 2009?
Your answer should be compact. 0.51. What is the ratio of the Total reserves (current US$) of Angola in 2006 to that in 2010?
Offer a very short reply. 0.44. What is the ratio of the Total reserves (current US$) of Cameroon in 2006 to that in 2010?
Provide a short and direct response. 0.47. What is the ratio of the Total reserves (current US$) in Sao Tome and Principe in 2006 to that in 2010?
Your answer should be compact. 0.71. What is the ratio of the Total reserves (current US$) in Angola in 2007 to that in 2008?
Ensure brevity in your answer.  0.63. What is the ratio of the Total reserves (current US$) in Cameroon in 2007 to that in 2008?
Keep it short and to the point. 0.94. What is the ratio of the Total reserves (current US$) in Sao Tome and Principe in 2007 to that in 2008?
Provide a short and direct response. 0.64. What is the ratio of the Total reserves (current US$) of Angola in 2007 to that in 2009?
Provide a short and direct response. 0.82. What is the ratio of the Total reserves (current US$) of Cameroon in 2007 to that in 2009?
Your answer should be compact. 0.79. What is the ratio of the Total reserves (current US$) in Sao Tome and Principe in 2007 to that in 2009?
Provide a short and direct response. 0.59. What is the ratio of the Total reserves (current US$) of Angola in 2007 to that in 2010?
Provide a succinct answer. 0.57. What is the ratio of the Total reserves (current US$) of Cameroon in 2007 to that in 2010?
Offer a terse response. 0.8. What is the ratio of the Total reserves (current US$) in Sao Tome and Principe in 2007 to that in 2010?
Ensure brevity in your answer.  0.82. What is the ratio of the Total reserves (current US$) of Angola in 2008 to that in 2009?
Your answer should be very brief. 1.31. What is the ratio of the Total reserves (current US$) in Cameroon in 2008 to that in 2009?
Offer a very short reply. 0.84. What is the ratio of the Total reserves (current US$) in Sao Tome and Principe in 2008 to that in 2009?
Keep it short and to the point. 0.92. What is the ratio of the Total reserves (current US$) of Angola in 2008 to that in 2010?
Offer a terse response. 0.9. What is the ratio of the Total reserves (current US$) of Cameroon in 2008 to that in 2010?
Ensure brevity in your answer.  0.85. What is the ratio of the Total reserves (current US$) in Sao Tome and Principe in 2008 to that in 2010?
Offer a very short reply. 1.27. What is the ratio of the Total reserves (current US$) in Angola in 2009 to that in 2010?
Your answer should be very brief. 0.69. What is the ratio of the Total reserves (current US$) in Sao Tome and Principe in 2009 to that in 2010?
Provide a short and direct response. 1.38. What is the difference between the highest and the second highest Total reserves (current US$) of Angola?
Your response must be concise. 1.88e+09. What is the difference between the highest and the second highest Total reserves (current US$) in Cameroon?
Give a very brief answer. 3.29e+07. What is the difference between the highest and the second highest Total reserves (current US$) in Sao Tome and Principe?
Make the answer very short. 5.37e+06. What is the difference between the highest and the lowest Total reserves (current US$) of Angola?
Offer a very short reply. 1.91e+1. What is the difference between the highest and the lowest Total reserves (current US$) of Cameroon?
Keep it short and to the point. 3.04e+09. What is the difference between the highest and the lowest Total reserves (current US$) of Sao Tome and Principe?
Make the answer very short. 4.72e+07. 